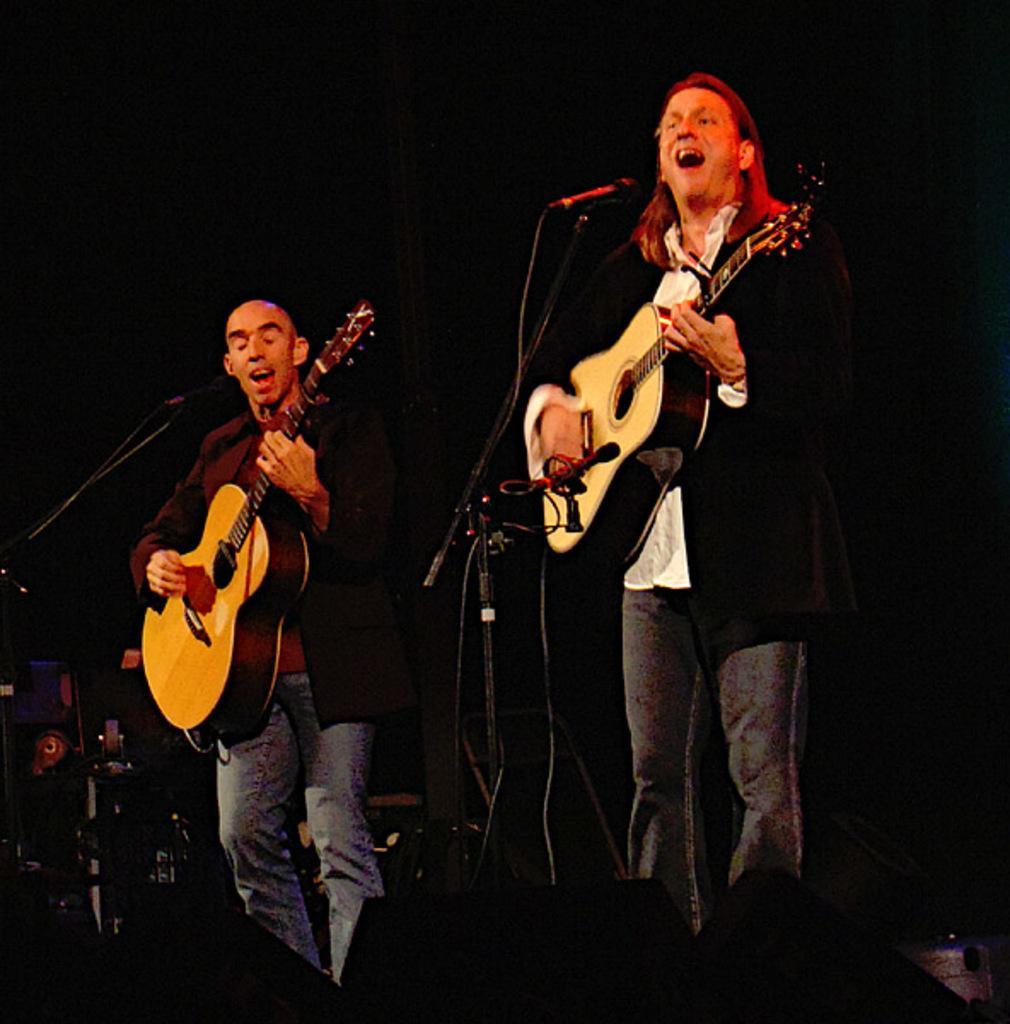Can you describe this image briefly? in this image i can see a person playing music an holding a guitar and both mouth is open and there are some musical instruments kept on left side. 